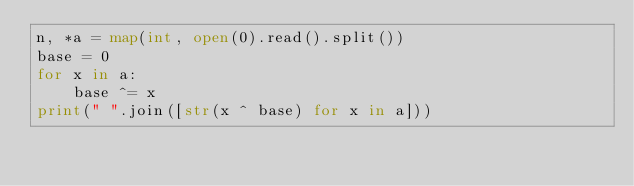<code> <loc_0><loc_0><loc_500><loc_500><_Python_>n, *a = map(int, open(0).read().split())
base = 0
for x in a:
    base ^= x
print(" ".join([str(x ^ base) for x in a]))
</code> 